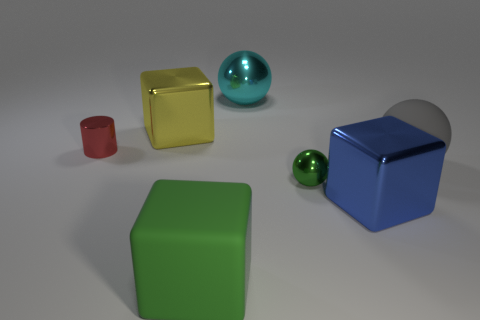What might be the relative sizes of the objects? The rectangular green block appears to be the largest, followed by the blue cube, the yellow cube, the red cylinder, the larger green sphere, and finally the smaller green sphere as the smallest. 